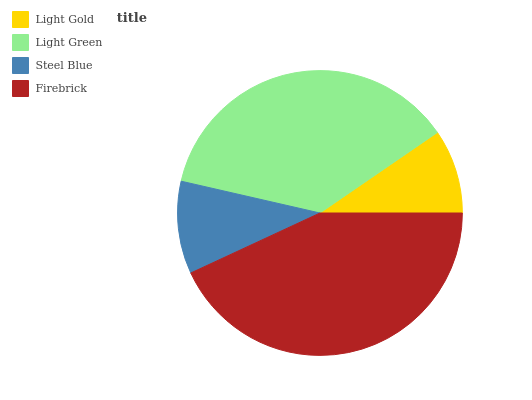Is Light Gold the minimum?
Answer yes or no. Yes. Is Firebrick the maximum?
Answer yes or no. Yes. Is Light Green the minimum?
Answer yes or no. No. Is Light Green the maximum?
Answer yes or no. No. Is Light Green greater than Light Gold?
Answer yes or no. Yes. Is Light Gold less than Light Green?
Answer yes or no. Yes. Is Light Gold greater than Light Green?
Answer yes or no. No. Is Light Green less than Light Gold?
Answer yes or no. No. Is Light Green the high median?
Answer yes or no. Yes. Is Steel Blue the low median?
Answer yes or no. Yes. Is Light Gold the high median?
Answer yes or no. No. Is Light Green the low median?
Answer yes or no. No. 